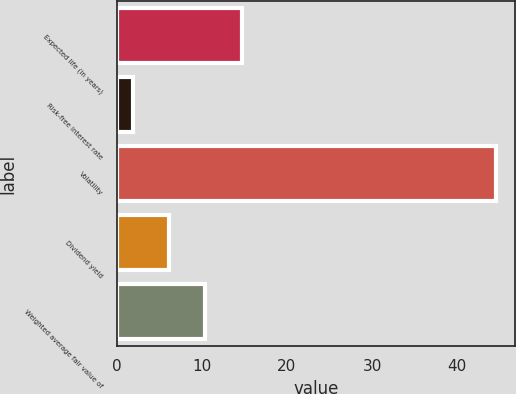Convert chart to OTSL. <chart><loc_0><loc_0><loc_500><loc_500><bar_chart><fcel>Expected life (in years)<fcel>Risk-free interest rate<fcel>Volatility<fcel>Dividend yield<fcel>Weighted average fair value of<nl><fcel>14.68<fcel>1.87<fcel>44.6<fcel>6.14<fcel>10.41<nl></chart> 